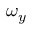<formula> <loc_0><loc_0><loc_500><loc_500>\omega _ { y }</formula> 